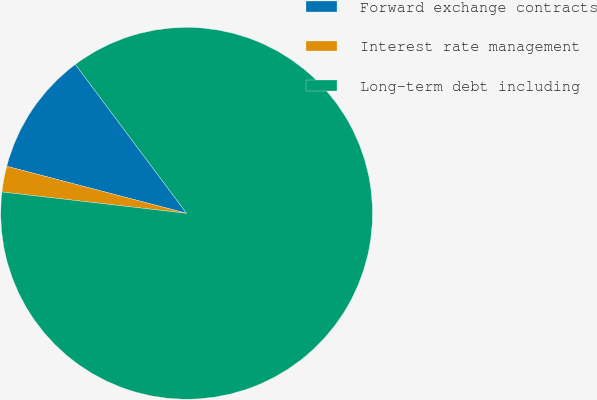Convert chart to OTSL. <chart><loc_0><loc_0><loc_500><loc_500><pie_chart><fcel>Forward exchange contracts<fcel>Interest rate management<fcel>Long-term debt including<nl><fcel>10.72%<fcel>2.24%<fcel>87.04%<nl></chart> 